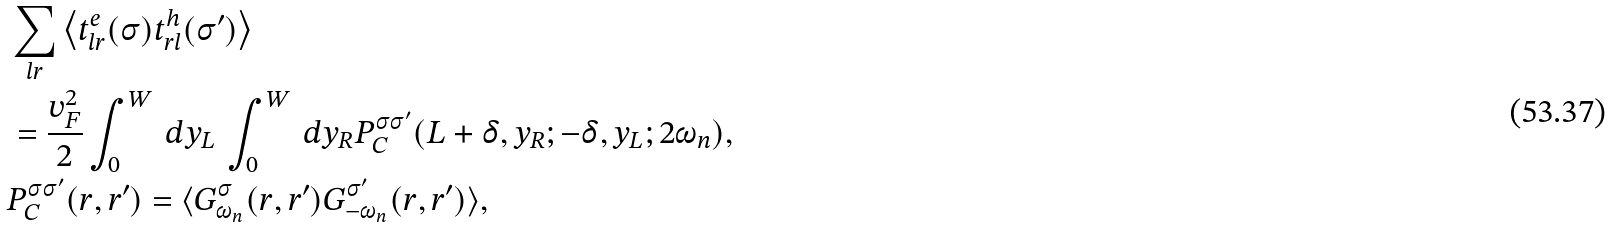Convert formula to latex. <formula><loc_0><loc_0><loc_500><loc_500>& \sum _ { l r } \left \langle t _ { l r } ^ { e } ( \sigma ) t _ { r l } ^ { h } ( { \sigma } ^ { \prime } ) \right \rangle \\ & = \frac { v _ { F } ^ { 2 } } { 2 } \int _ { 0 } ^ { W } \, d y _ { L } \, \int _ { 0 } ^ { W } \, d y _ { R } P _ { C } ^ { \sigma { \sigma } ^ { \prime } } ( L + \delta , y _ { R } ; - \delta , y _ { L } ; 2 \omega _ { n } ) , \\ & P _ { C } ^ { \sigma { \sigma } ^ { \prime } } ( r , r ^ { \prime } ) = \langle G _ { \omega _ { n } } ^ { \sigma } ( r , r ^ { \prime } ) G _ { - \omega _ { n } } ^ { \sigma ^ { \prime } } ( r , r ^ { \prime } ) \rangle ,</formula> 